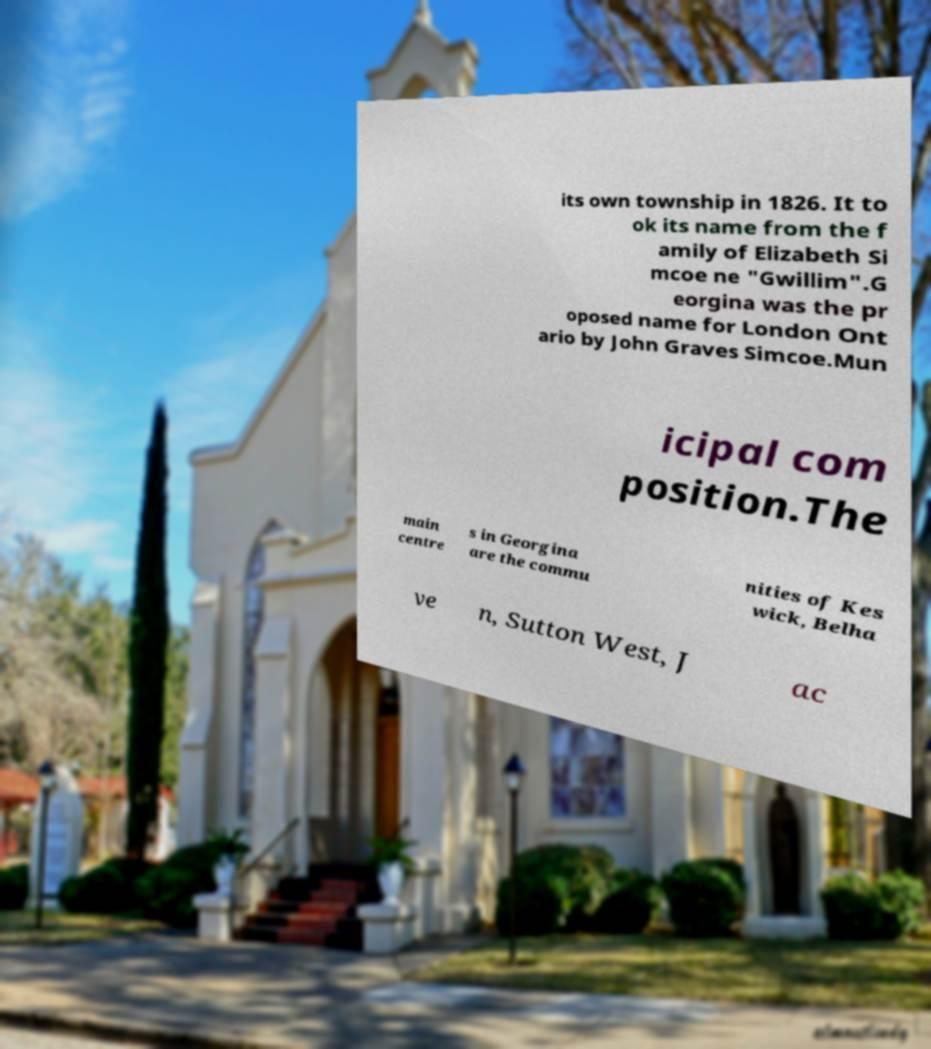I need the written content from this picture converted into text. Can you do that? its own township in 1826. It to ok its name from the f amily of Elizabeth Si mcoe ne "Gwillim".G eorgina was the pr oposed name for London Ont ario by John Graves Simcoe.Mun icipal com position.The main centre s in Georgina are the commu nities of Kes wick, Belha ve n, Sutton West, J ac 